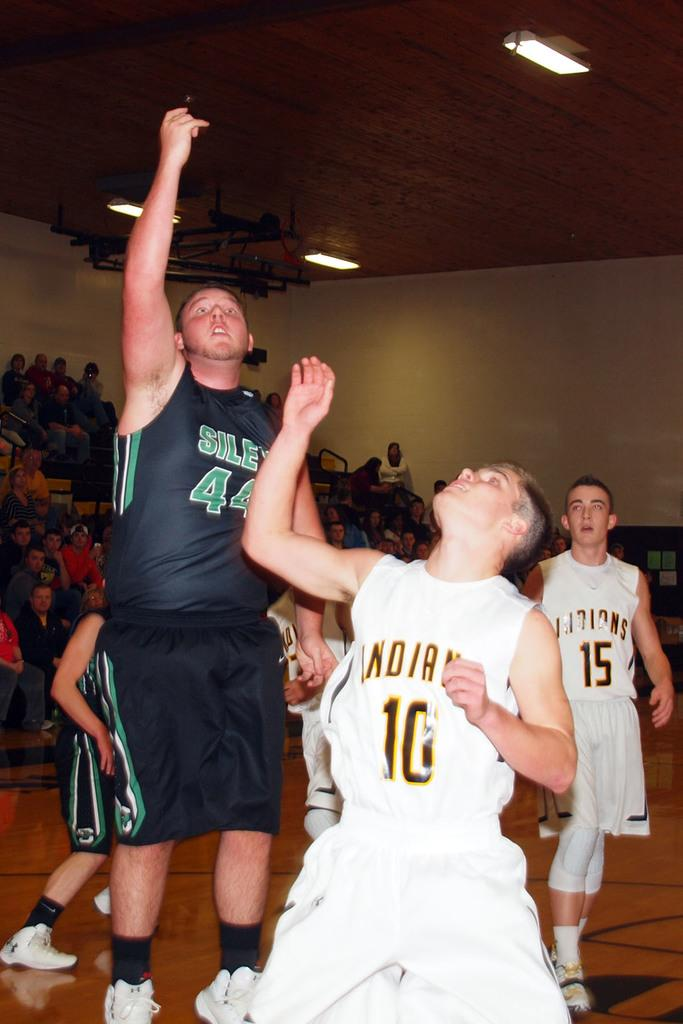<image>
Give a short and clear explanation of the subsequent image. The Indians are playing against another team while onlookers are seen sitting in the bleachers in the background. 